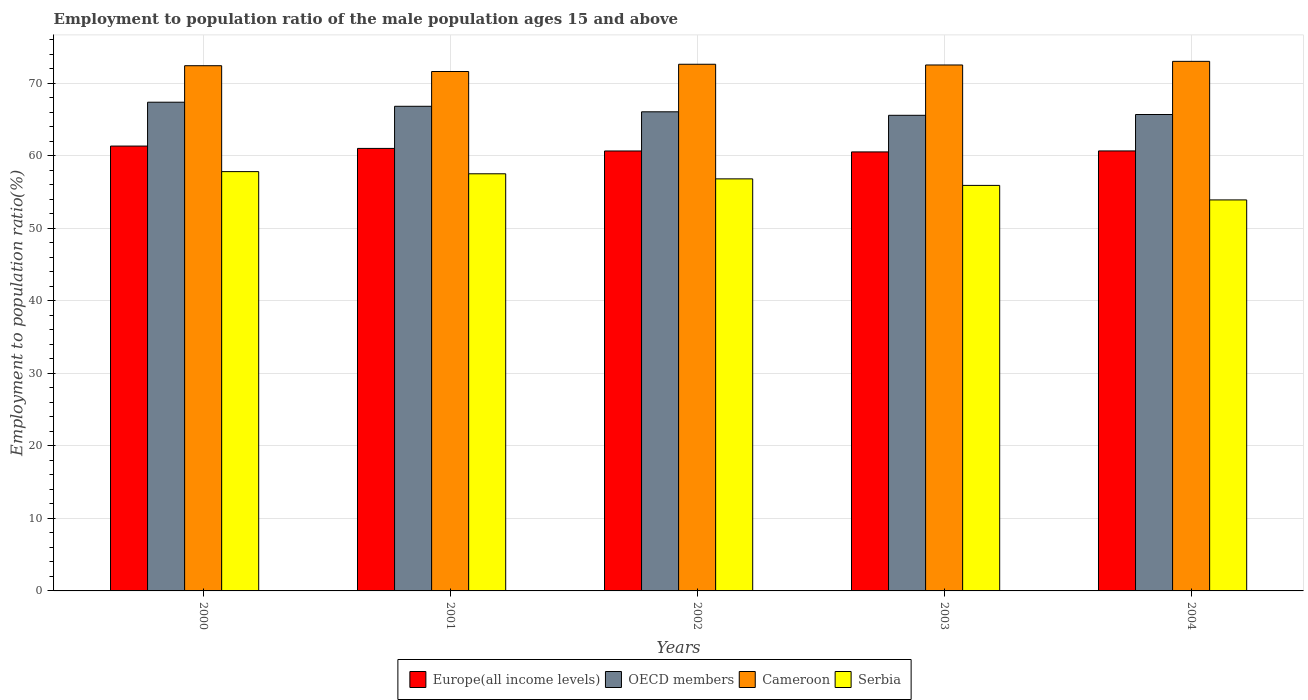Are the number of bars on each tick of the X-axis equal?
Keep it short and to the point. Yes. How many bars are there on the 2nd tick from the left?
Offer a terse response. 4. What is the label of the 2nd group of bars from the left?
Your response must be concise. 2001. What is the employment to population ratio in Serbia in 2002?
Give a very brief answer. 56.8. Across all years, what is the maximum employment to population ratio in Europe(all income levels)?
Give a very brief answer. 61.32. Across all years, what is the minimum employment to population ratio in Cameroon?
Provide a short and direct response. 71.6. What is the total employment to population ratio in OECD members in the graph?
Provide a short and direct response. 331.45. What is the difference between the employment to population ratio in Cameroon in 2000 and that in 2001?
Provide a short and direct response. 0.8. What is the difference between the employment to population ratio in Serbia in 2000 and the employment to population ratio in Cameroon in 2001?
Offer a very short reply. -13.8. What is the average employment to population ratio in Serbia per year?
Your answer should be compact. 56.38. In the year 2004, what is the difference between the employment to population ratio in Serbia and employment to population ratio in Europe(all income levels)?
Your answer should be compact. -6.75. In how many years, is the employment to population ratio in Cameroon greater than 62 %?
Your answer should be compact. 5. What is the ratio of the employment to population ratio in Europe(all income levels) in 2000 to that in 2002?
Provide a succinct answer. 1.01. Is the employment to population ratio in Cameroon in 2000 less than that in 2002?
Keep it short and to the point. Yes. Is the difference between the employment to population ratio in Serbia in 2001 and 2003 greater than the difference between the employment to population ratio in Europe(all income levels) in 2001 and 2003?
Your response must be concise. Yes. What is the difference between the highest and the second highest employment to population ratio in Serbia?
Your answer should be compact. 0.3. What is the difference between the highest and the lowest employment to population ratio in Europe(all income levels)?
Your response must be concise. 0.81. In how many years, is the employment to population ratio in Cameroon greater than the average employment to population ratio in Cameroon taken over all years?
Give a very brief answer. 3. What does the 1st bar from the left in 2004 represents?
Your answer should be very brief. Europe(all income levels). What does the 2nd bar from the right in 2000 represents?
Your answer should be very brief. Cameroon. How many bars are there?
Your answer should be very brief. 20. How many years are there in the graph?
Keep it short and to the point. 5. Are the values on the major ticks of Y-axis written in scientific E-notation?
Your answer should be compact. No. Does the graph contain any zero values?
Make the answer very short. No. Does the graph contain grids?
Offer a terse response. Yes. Where does the legend appear in the graph?
Your answer should be compact. Bottom center. What is the title of the graph?
Your answer should be compact. Employment to population ratio of the male population ages 15 and above. Does "Hong Kong" appear as one of the legend labels in the graph?
Keep it short and to the point. No. What is the label or title of the Y-axis?
Offer a terse response. Employment to population ratio(%). What is the Employment to population ratio(%) of Europe(all income levels) in 2000?
Your response must be concise. 61.32. What is the Employment to population ratio(%) of OECD members in 2000?
Give a very brief answer. 67.37. What is the Employment to population ratio(%) in Cameroon in 2000?
Keep it short and to the point. 72.4. What is the Employment to population ratio(%) in Serbia in 2000?
Your response must be concise. 57.8. What is the Employment to population ratio(%) in Europe(all income levels) in 2001?
Give a very brief answer. 61. What is the Employment to population ratio(%) of OECD members in 2001?
Offer a terse response. 66.81. What is the Employment to population ratio(%) in Cameroon in 2001?
Make the answer very short. 71.6. What is the Employment to population ratio(%) of Serbia in 2001?
Provide a succinct answer. 57.5. What is the Employment to population ratio(%) in Europe(all income levels) in 2002?
Provide a succinct answer. 60.65. What is the Employment to population ratio(%) in OECD members in 2002?
Give a very brief answer. 66.05. What is the Employment to population ratio(%) in Cameroon in 2002?
Offer a terse response. 72.6. What is the Employment to population ratio(%) in Serbia in 2002?
Ensure brevity in your answer.  56.8. What is the Employment to population ratio(%) in Europe(all income levels) in 2003?
Keep it short and to the point. 60.52. What is the Employment to population ratio(%) in OECD members in 2003?
Your answer should be compact. 65.56. What is the Employment to population ratio(%) in Cameroon in 2003?
Your answer should be very brief. 72.5. What is the Employment to population ratio(%) of Serbia in 2003?
Ensure brevity in your answer.  55.9. What is the Employment to population ratio(%) in Europe(all income levels) in 2004?
Your answer should be very brief. 60.65. What is the Employment to population ratio(%) in OECD members in 2004?
Provide a succinct answer. 65.67. What is the Employment to population ratio(%) in Serbia in 2004?
Provide a short and direct response. 53.9. Across all years, what is the maximum Employment to population ratio(%) of Europe(all income levels)?
Provide a short and direct response. 61.32. Across all years, what is the maximum Employment to population ratio(%) in OECD members?
Make the answer very short. 67.37. Across all years, what is the maximum Employment to population ratio(%) of Serbia?
Keep it short and to the point. 57.8. Across all years, what is the minimum Employment to population ratio(%) of Europe(all income levels)?
Give a very brief answer. 60.52. Across all years, what is the minimum Employment to population ratio(%) in OECD members?
Ensure brevity in your answer.  65.56. Across all years, what is the minimum Employment to population ratio(%) of Cameroon?
Your answer should be very brief. 71.6. Across all years, what is the minimum Employment to population ratio(%) of Serbia?
Provide a succinct answer. 53.9. What is the total Employment to population ratio(%) of Europe(all income levels) in the graph?
Give a very brief answer. 304.13. What is the total Employment to population ratio(%) in OECD members in the graph?
Your answer should be very brief. 331.45. What is the total Employment to population ratio(%) in Cameroon in the graph?
Keep it short and to the point. 362.1. What is the total Employment to population ratio(%) of Serbia in the graph?
Keep it short and to the point. 281.9. What is the difference between the Employment to population ratio(%) of Europe(all income levels) in 2000 and that in 2001?
Provide a succinct answer. 0.32. What is the difference between the Employment to population ratio(%) in OECD members in 2000 and that in 2001?
Keep it short and to the point. 0.56. What is the difference between the Employment to population ratio(%) in Cameroon in 2000 and that in 2001?
Your answer should be very brief. 0.8. What is the difference between the Employment to population ratio(%) of Europe(all income levels) in 2000 and that in 2002?
Give a very brief answer. 0.68. What is the difference between the Employment to population ratio(%) in OECD members in 2000 and that in 2002?
Give a very brief answer. 1.32. What is the difference between the Employment to population ratio(%) in Cameroon in 2000 and that in 2002?
Provide a short and direct response. -0.2. What is the difference between the Employment to population ratio(%) in Serbia in 2000 and that in 2002?
Your answer should be very brief. 1. What is the difference between the Employment to population ratio(%) in Europe(all income levels) in 2000 and that in 2003?
Offer a terse response. 0.81. What is the difference between the Employment to population ratio(%) of OECD members in 2000 and that in 2003?
Provide a succinct answer. 1.8. What is the difference between the Employment to population ratio(%) in Serbia in 2000 and that in 2003?
Your answer should be compact. 1.9. What is the difference between the Employment to population ratio(%) of Europe(all income levels) in 2000 and that in 2004?
Keep it short and to the point. 0.67. What is the difference between the Employment to population ratio(%) of OECD members in 2000 and that in 2004?
Provide a short and direct response. 1.69. What is the difference between the Employment to population ratio(%) in Cameroon in 2000 and that in 2004?
Offer a very short reply. -0.6. What is the difference between the Employment to population ratio(%) in Serbia in 2000 and that in 2004?
Provide a short and direct response. 3.9. What is the difference between the Employment to population ratio(%) of Europe(all income levels) in 2001 and that in 2002?
Provide a short and direct response. 0.35. What is the difference between the Employment to population ratio(%) in OECD members in 2001 and that in 2002?
Keep it short and to the point. 0.76. What is the difference between the Employment to population ratio(%) of Europe(all income levels) in 2001 and that in 2003?
Offer a terse response. 0.48. What is the difference between the Employment to population ratio(%) of OECD members in 2001 and that in 2003?
Your answer should be very brief. 1.24. What is the difference between the Employment to population ratio(%) in Cameroon in 2001 and that in 2003?
Your answer should be very brief. -0.9. What is the difference between the Employment to population ratio(%) of Europe(all income levels) in 2001 and that in 2004?
Provide a succinct answer. 0.35. What is the difference between the Employment to population ratio(%) in OECD members in 2001 and that in 2004?
Ensure brevity in your answer.  1.13. What is the difference between the Employment to population ratio(%) of Europe(all income levels) in 2002 and that in 2003?
Offer a very short reply. 0.13. What is the difference between the Employment to population ratio(%) of OECD members in 2002 and that in 2003?
Ensure brevity in your answer.  0.48. What is the difference between the Employment to population ratio(%) of Cameroon in 2002 and that in 2003?
Offer a very short reply. 0.1. What is the difference between the Employment to population ratio(%) of Europe(all income levels) in 2002 and that in 2004?
Your response must be concise. -0.01. What is the difference between the Employment to population ratio(%) of OECD members in 2002 and that in 2004?
Your answer should be very brief. 0.37. What is the difference between the Employment to population ratio(%) of Serbia in 2002 and that in 2004?
Offer a terse response. 2.9. What is the difference between the Employment to population ratio(%) of Europe(all income levels) in 2003 and that in 2004?
Give a very brief answer. -0.14. What is the difference between the Employment to population ratio(%) in OECD members in 2003 and that in 2004?
Make the answer very short. -0.11. What is the difference between the Employment to population ratio(%) in Cameroon in 2003 and that in 2004?
Provide a short and direct response. -0.5. What is the difference between the Employment to population ratio(%) in Serbia in 2003 and that in 2004?
Offer a very short reply. 2. What is the difference between the Employment to population ratio(%) in Europe(all income levels) in 2000 and the Employment to population ratio(%) in OECD members in 2001?
Give a very brief answer. -5.48. What is the difference between the Employment to population ratio(%) in Europe(all income levels) in 2000 and the Employment to population ratio(%) in Cameroon in 2001?
Your answer should be compact. -10.28. What is the difference between the Employment to population ratio(%) in Europe(all income levels) in 2000 and the Employment to population ratio(%) in Serbia in 2001?
Offer a terse response. 3.82. What is the difference between the Employment to population ratio(%) of OECD members in 2000 and the Employment to population ratio(%) of Cameroon in 2001?
Make the answer very short. -4.23. What is the difference between the Employment to population ratio(%) in OECD members in 2000 and the Employment to population ratio(%) in Serbia in 2001?
Your answer should be compact. 9.87. What is the difference between the Employment to population ratio(%) in Cameroon in 2000 and the Employment to population ratio(%) in Serbia in 2001?
Offer a terse response. 14.9. What is the difference between the Employment to population ratio(%) in Europe(all income levels) in 2000 and the Employment to population ratio(%) in OECD members in 2002?
Your response must be concise. -4.72. What is the difference between the Employment to population ratio(%) of Europe(all income levels) in 2000 and the Employment to population ratio(%) of Cameroon in 2002?
Make the answer very short. -11.28. What is the difference between the Employment to population ratio(%) in Europe(all income levels) in 2000 and the Employment to population ratio(%) in Serbia in 2002?
Make the answer very short. 4.52. What is the difference between the Employment to population ratio(%) in OECD members in 2000 and the Employment to population ratio(%) in Cameroon in 2002?
Ensure brevity in your answer.  -5.23. What is the difference between the Employment to population ratio(%) in OECD members in 2000 and the Employment to population ratio(%) in Serbia in 2002?
Provide a short and direct response. 10.57. What is the difference between the Employment to population ratio(%) in Cameroon in 2000 and the Employment to population ratio(%) in Serbia in 2002?
Provide a short and direct response. 15.6. What is the difference between the Employment to population ratio(%) of Europe(all income levels) in 2000 and the Employment to population ratio(%) of OECD members in 2003?
Ensure brevity in your answer.  -4.24. What is the difference between the Employment to population ratio(%) of Europe(all income levels) in 2000 and the Employment to population ratio(%) of Cameroon in 2003?
Your response must be concise. -11.18. What is the difference between the Employment to population ratio(%) of Europe(all income levels) in 2000 and the Employment to population ratio(%) of Serbia in 2003?
Make the answer very short. 5.42. What is the difference between the Employment to population ratio(%) of OECD members in 2000 and the Employment to population ratio(%) of Cameroon in 2003?
Provide a succinct answer. -5.13. What is the difference between the Employment to population ratio(%) in OECD members in 2000 and the Employment to population ratio(%) in Serbia in 2003?
Keep it short and to the point. 11.47. What is the difference between the Employment to population ratio(%) of Europe(all income levels) in 2000 and the Employment to population ratio(%) of OECD members in 2004?
Ensure brevity in your answer.  -4.35. What is the difference between the Employment to population ratio(%) in Europe(all income levels) in 2000 and the Employment to population ratio(%) in Cameroon in 2004?
Your answer should be compact. -11.68. What is the difference between the Employment to population ratio(%) of Europe(all income levels) in 2000 and the Employment to population ratio(%) of Serbia in 2004?
Offer a terse response. 7.42. What is the difference between the Employment to population ratio(%) in OECD members in 2000 and the Employment to population ratio(%) in Cameroon in 2004?
Your answer should be compact. -5.63. What is the difference between the Employment to population ratio(%) of OECD members in 2000 and the Employment to population ratio(%) of Serbia in 2004?
Your answer should be compact. 13.47. What is the difference between the Employment to population ratio(%) in Cameroon in 2000 and the Employment to population ratio(%) in Serbia in 2004?
Provide a short and direct response. 18.5. What is the difference between the Employment to population ratio(%) in Europe(all income levels) in 2001 and the Employment to population ratio(%) in OECD members in 2002?
Make the answer very short. -5.05. What is the difference between the Employment to population ratio(%) of Europe(all income levels) in 2001 and the Employment to population ratio(%) of Cameroon in 2002?
Your response must be concise. -11.6. What is the difference between the Employment to population ratio(%) of Europe(all income levels) in 2001 and the Employment to population ratio(%) of Serbia in 2002?
Your response must be concise. 4.2. What is the difference between the Employment to population ratio(%) of OECD members in 2001 and the Employment to population ratio(%) of Cameroon in 2002?
Keep it short and to the point. -5.79. What is the difference between the Employment to population ratio(%) of OECD members in 2001 and the Employment to population ratio(%) of Serbia in 2002?
Ensure brevity in your answer.  10.01. What is the difference between the Employment to population ratio(%) of Europe(all income levels) in 2001 and the Employment to population ratio(%) of OECD members in 2003?
Offer a very short reply. -4.57. What is the difference between the Employment to population ratio(%) of Europe(all income levels) in 2001 and the Employment to population ratio(%) of Cameroon in 2003?
Your answer should be very brief. -11.5. What is the difference between the Employment to population ratio(%) of Europe(all income levels) in 2001 and the Employment to population ratio(%) of Serbia in 2003?
Your answer should be very brief. 5.1. What is the difference between the Employment to population ratio(%) of OECD members in 2001 and the Employment to population ratio(%) of Cameroon in 2003?
Provide a short and direct response. -5.69. What is the difference between the Employment to population ratio(%) in OECD members in 2001 and the Employment to population ratio(%) in Serbia in 2003?
Provide a succinct answer. 10.91. What is the difference between the Employment to population ratio(%) of Cameroon in 2001 and the Employment to population ratio(%) of Serbia in 2003?
Your answer should be very brief. 15.7. What is the difference between the Employment to population ratio(%) of Europe(all income levels) in 2001 and the Employment to population ratio(%) of OECD members in 2004?
Your response must be concise. -4.67. What is the difference between the Employment to population ratio(%) of Europe(all income levels) in 2001 and the Employment to population ratio(%) of Cameroon in 2004?
Give a very brief answer. -12. What is the difference between the Employment to population ratio(%) in Europe(all income levels) in 2001 and the Employment to population ratio(%) in Serbia in 2004?
Keep it short and to the point. 7.1. What is the difference between the Employment to population ratio(%) in OECD members in 2001 and the Employment to population ratio(%) in Cameroon in 2004?
Your answer should be very brief. -6.19. What is the difference between the Employment to population ratio(%) in OECD members in 2001 and the Employment to population ratio(%) in Serbia in 2004?
Offer a very short reply. 12.91. What is the difference between the Employment to population ratio(%) in Cameroon in 2001 and the Employment to population ratio(%) in Serbia in 2004?
Make the answer very short. 17.7. What is the difference between the Employment to population ratio(%) of Europe(all income levels) in 2002 and the Employment to population ratio(%) of OECD members in 2003?
Your answer should be compact. -4.92. What is the difference between the Employment to population ratio(%) in Europe(all income levels) in 2002 and the Employment to population ratio(%) in Cameroon in 2003?
Offer a very short reply. -11.85. What is the difference between the Employment to population ratio(%) in Europe(all income levels) in 2002 and the Employment to population ratio(%) in Serbia in 2003?
Your response must be concise. 4.75. What is the difference between the Employment to population ratio(%) in OECD members in 2002 and the Employment to population ratio(%) in Cameroon in 2003?
Your answer should be very brief. -6.45. What is the difference between the Employment to population ratio(%) in OECD members in 2002 and the Employment to population ratio(%) in Serbia in 2003?
Your response must be concise. 10.15. What is the difference between the Employment to population ratio(%) of Cameroon in 2002 and the Employment to population ratio(%) of Serbia in 2003?
Give a very brief answer. 16.7. What is the difference between the Employment to population ratio(%) in Europe(all income levels) in 2002 and the Employment to population ratio(%) in OECD members in 2004?
Your answer should be compact. -5.03. What is the difference between the Employment to population ratio(%) of Europe(all income levels) in 2002 and the Employment to population ratio(%) of Cameroon in 2004?
Give a very brief answer. -12.35. What is the difference between the Employment to population ratio(%) in Europe(all income levels) in 2002 and the Employment to population ratio(%) in Serbia in 2004?
Ensure brevity in your answer.  6.75. What is the difference between the Employment to population ratio(%) of OECD members in 2002 and the Employment to population ratio(%) of Cameroon in 2004?
Make the answer very short. -6.95. What is the difference between the Employment to population ratio(%) in OECD members in 2002 and the Employment to population ratio(%) in Serbia in 2004?
Make the answer very short. 12.15. What is the difference between the Employment to population ratio(%) of Europe(all income levels) in 2003 and the Employment to population ratio(%) of OECD members in 2004?
Your answer should be compact. -5.16. What is the difference between the Employment to population ratio(%) in Europe(all income levels) in 2003 and the Employment to population ratio(%) in Cameroon in 2004?
Your answer should be compact. -12.48. What is the difference between the Employment to population ratio(%) of Europe(all income levels) in 2003 and the Employment to population ratio(%) of Serbia in 2004?
Keep it short and to the point. 6.62. What is the difference between the Employment to population ratio(%) in OECD members in 2003 and the Employment to population ratio(%) in Cameroon in 2004?
Give a very brief answer. -7.44. What is the difference between the Employment to population ratio(%) in OECD members in 2003 and the Employment to population ratio(%) in Serbia in 2004?
Provide a short and direct response. 11.66. What is the average Employment to population ratio(%) in Europe(all income levels) per year?
Make the answer very short. 60.83. What is the average Employment to population ratio(%) of OECD members per year?
Your response must be concise. 66.29. What is the average Employment to population ratio(%) in Cameroon per year?
Keep it short and to the point. 72.42. What is the average Employment to population ratio(%) in Serbia per year?
Keep it short and to the point. 56.38. In the year 2000, what is the difference between the Employment to population ratio(%) in Europe(all income levels) and Employment to population ratio(%) in OECD members?
Make the answer very short. -6.04. In the year 2000, what is the difference between the Employment to population ratio(%) of Europe(all income levels) and Employment to population ratio(%) of Cameroon?
Offer a very short reply. -11.08. In the year 2000, what is the difference between the Employment to population ratio(%) of Europe(all income levels) and Employment to population ratio(%) of Serbia?
Offer a terse response. 3.52. In the year 2000, what is the difference between the Employment to population ratio(%) of OECD members and Employment to population ratio(%) of Cameroon?
Offer a terse response. -5.03. In the year 2000, what is the difference between the Employment to population ratio(%) in OECD members and Employment to population ratio(%) in Serbia?
Your answer should be very brief. 9.57. In the year 2000, what is the difference between the Employment to population ratio(%) in Cameroon and Employment to population ratio(%) in Serbia?
Your answer should be very brief. 14.6. In the year 2001, what is the difference between the Employment to population ratio(%) of Europe(all income levels) and Employment to population ratio(%) of OECD members?
Provide a succinct answer. -5.81. In the year 2001, what is the difference between the Employment to population ratio(%) of Europe(all income levels) and Employment to population ratio(%) of Cameroon?
Ensure brevity in your answer.  -10.6. In the year 2001, what is the difference between the Employment to population ratio(%) in Europe(all income levels) and Employment to population ratio(%) in Serbia?
Provide a succinct answer. 3.5. In the year 2001, what is the difference between the Employment to population ratio(%) in OECD members and Employment to population ratio(%) in Cameroon?
Your answer should be compact. -4.79. In the year 2001, what is the difference between the Employment to population ratio(%) in OECD members and Employment to population ratio(%) in Serbia?
Your answer should be very brief. 9.31. In the year 2001, what is the difference between the Employment to population ratio(%) of Cameroon and Employment to population ratio(%) of Serbia?
Your response must be concise. 14.1. In the year 2002, what is the difference between the Employment to population ratio(%) of Europe(all income levels) and Employment to population ratio(%) of OECD members?
Provide a succinct answer. -5.4. In the year 2002, what is the difference between the Employment to population ratio(%) of Europe(all income levels) and Employment to population ratio(%) of Cameroon?
Ensure brevity in your answer.  -11.95. In the year 2002, what is the difference between the Employment to population ratio(%) of Europe(all income levels) and Employment to population ratio(%) of Serbia?
Provide a succinct answer. 3.85. In the year 2002, what is the difference between the Employment to population ratio(%) of OECD members and Employment to population ratio(%) of Cameroon?
Provide a succinct answer. -6.55. In the year 2002, what is the difference between the Employment to population ratio(%) in OECD members and Employment to population ratio(%) in Serbia?
Provide a short and direct response. 9.25. In the year 2002, what is the difference between the Employment to population ratio(%) in Cameroon and Employment to population ratio(%) in Serbia?
Your answer should be very brief. 15.8. In the year 2003, what is the difference between the Employment to population ratio(%) of Europe(all income levels) and Employment to population ratio(%) of OECD members?
Offer a terse response. -5.05. In the year 2003, what is the difference between the Employment to population ratio(%) of Europe(all income levels) and Employment to population ratio(%) of Cameroon?
Give a very brief answer. -11.98. In the year 2003, what is the difference between the Employment to population ratio(%) of Europe(all income levels) and Employment to population ratio(%) of Serbia?
Provide a short and direct response. 4.62. In the year 2003, what is the difference between the Employment to population ratio(%) of OECD members and Employment to population ratio(%) of Cameroon?
Offer a terse response. -6.94. In the year 2003, what is the difference between the Employment to population ratio(%) in OECD members and Employment to population ratio(%) in Serbia?
Provide a succinct answer. 9.66. In the year 2003, what is the difference between the Employment to population ratio(%) in Cameroon and Employment to population ratio(%) in Serbia?
Provide a short and direct response. 16.6. In the year 2004, what is the difference between the Employment to population ratio(%) of Europe(all income levels) and Employment to population ratio(%) of OECD members?
Keep it short and to the point. -5.02. In the year 2004, what is the difference between the Employment to population ratio(%) in Europe(all income levels) and Employment to population ratio(%) in Cameroon?
Offer a terse response. -12.35. In the year 2004, what is the difference between the Employment to population ratio(%) in Europe(all income levels) and Employment to population ratio(%) in Serbia?
Make the answer very short. 6.75. In the year 2004, what is the difference between the Employment to population ratio(%) of OECD members and Employment to population ratio(%) of Cameroon?
Your response must be concise. -7.33. In the year 2004, what is the difference between the Employment to population ratio(%) of OECD members and Employment to population ratio(%) of Serbia?
Provide a short and direct response. 11.77. In the year 2004, what is the difference between the Employment to population ratio(%) in Cameroon and Employment to population ratio(%) in Serbia?
Offer a very short reply. 19.1. What is the ratio of the Employment to population ratio(%) in Europe(all income levels) in 2000 to that in 2001?
Your answer should be very brief. 1.01. What is the ratio of the Employment to population ratio(%) in OECD members in 2000 to that in 2001?
Provide a short and direct response. 1.01. What is the ratio of the Employment to population ratio(%) in Cameroon in 2000 to that in 2001?
Your answer should be compact. 1.01. What is the ratio of the Employment to population ratio(%) of Europe(all income levels) in 2000 to that in 2002?
Provide a succinct answer. 1.01. What is the ratio of the Employment to population ratio(%) of OECD members in 2000 to that in 2002?
Offer a very short reply. 1.02. What is the ratio of the Employment to population ratio(%) of Cameroon in 2000 to that in 2002?
Give a very brief answer. 1. What is the ratio of the Employment to population ratio(%) in Serbia in 2000 to that in 2002?
Offer a terse response. 1.02. What is the ratio of the Employment to population ratio(%) of Europe(all income levels) in 2000 to that in 2003?
Ensure brevity in your answer.  1.01. What is the ratio of the Employment to population ratio(%) of OECD members in 2000 to that in 2003?
Ensure brevity in your answer.  1.03. What is the ratio of the Employment to population ratio(%) in Serbia in 2000 to that in 2003?
Your answer should be compact. 1.03. What is the ratio of the Employment to population ratio(%) of Europe(all income levels) in 2000 to that in 2004?
Make the answer very short. 1.01. What is the ratio of the Employment to population ratio(%) in OECD members in 2000 to that in 2004?
Make the answer very short. 1.03. What is the ratio of the Employment to population ratio(%) in Serbia in 2000 to that in 2004?
Your response must be concise. 1.07. What is the ratio of the Employment to population ratio(%) in OECD members in 2001 to that in 2002?
Provide a short and direct response. 1.01. What is the ratio of the Employment to population ratio(%) in Cameroon in 2001 to that in 2002?
Your response must be concise. 0.99. What is the ratio of the Employment to population ratio(%) of Serbia in 2001 to that in 2002?
Your answer should be very brief. 1.01. What is the ratio of the Employment to population ratio(%) of Europe(all income levels) in 2001 to that in 2003?
Your answer should be compact. 1.01. What is the ratio of the Employment to population ratio(%) in OECD members in 2001 to that in 2003?
Keep it short and to the point. 1.02. What is the ratio of the Employment to population ratio(%) in Cameroon in 2001 to that in 2003?
Ensure brevity in your answer.  0.99. What is the ratio of the Employment to population ratio(%) of Serbia in 2001 to that in 2003?
Ensure brevity in your answer.  1.03. What is the ratio of the Employment to population ratio(%) of OECD members in 2001 to that in 2004?
Make the answer very short. 1.02. What is the ratio of the Employment to population ratio(%) in Cameroon in 2001 to that in 2004?
Offer a terse response. 0.98. What is the ratio of the Employment to population ratio(%) of Serbia in 2001 to that in 2004?
Keep it short and to the point. 1.07. What is the ratio of the Employment to population ratio(%) in Europe(all income levels) in 2002 to that in 2003?
Provide a short and direct response. 1. What is the ratio of the Employment to population ratio(%) in OECD members in 2002 to that in 2003?
Make the answer very short. 1.01. What is the ratio of the Employment to population ratio(%) in Serbia in 2002 to that in 2003?
Offer a terse response. 1.02. What is the ratio of the Employment to population ratio(%) in Serbia in 2002 to that in 2004?
Your answer should be compact. 1.05. What is the ratio of the Employment to population ratio(%) in OECD members in 2003 to that in 2004?
Your answer should be very brief. 1. What is the ratio of the Employment to population ratio(%) in Cameroon in 2003 to that in 2004?
Keep it short and to the point. 0.99. What is the ratio of the Employment to population ratio(%) of Serbia in 2003 to that in 2004?
Provide a short and direct response. 1.04. What is the difference between the highest and the second highest Employment to population ratio(%) of Europe(all income levels)?
Your response must be concise. 0.32. What is the difference between the highest and the second highest Employment to population ratio(%) of OECD members?
Ensure brevity in your answer.  0.56. What is the difference between the highest and the second highest Employment to population ratio(%) of Cameroon?
Your response must be concise. 0.4. What is the difference between the highest and the lowest Employment to population ratio(%) of Europe(all income levels)?
Provide a short and direct response. 0.81. What is the difference between the highest and the lowest Employment to population ratio(%) in OECD members?
Offer a terse response. 1.8. What is the difference between the highest and the lowest Employment to population ratio(%) in Cameroon?
Offer a terse response. 1.4. What is the difference between the highest and the lowest Employment to population ratio(%) of Serbia?
Offer a terse response. 3.9. 